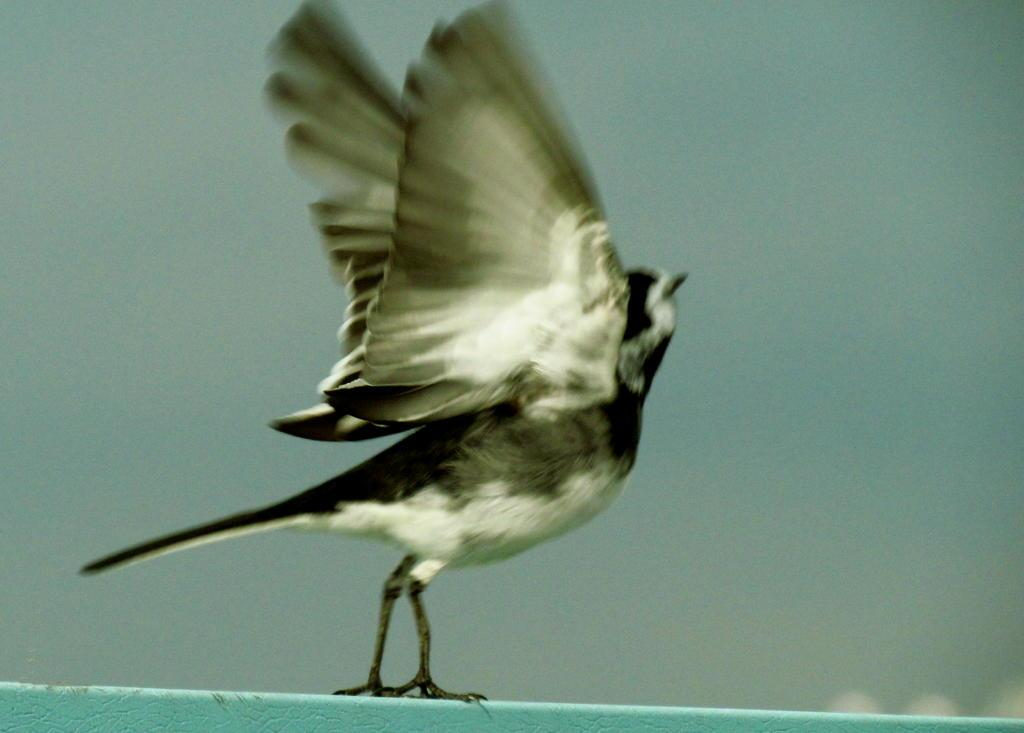What type of animal is present in the image? There is a bird in the image. What is the bird standing on? The bird is standing on a blue object. What is the bird's current action or state? The bird is about to fly. What type of drink is the bird holding in its beak in the image? There is no drink visible in the image; the bird is standing on a blue object and is about to fly. Is the bird wearing a scarf in the image? There is no scarf present in the image. 